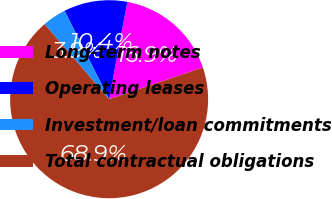<chart> <loc_0><loc_0><loc_500><loc_500><pie_chart><fcel>Long-term notes<fcel>Operating leases<fcel>Investment/loan commitments<fcel>Total contractual obligations<nl><fcel>16.87%<fcel>10.37%<fcel>3.87%<fcel>68.89%<nl></chart> 